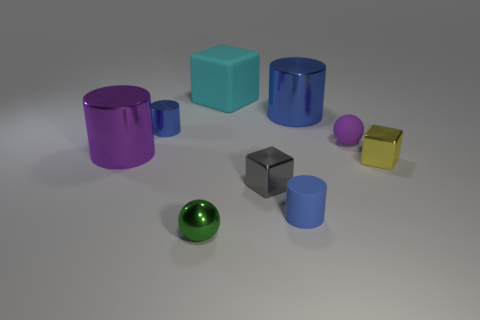There is a small cylinder on the right side of the large cyan block; is its color the same as the big shiny cylinder that is behind the tiny metal cylinder?
Ensure brevity in your answer.  Yes. Is the number of blue cylinders behind the purple rubber thing greater than the number of large blue objects?
Give a very brief answer. Yes. What is the material of the green ball?
Make the answer very short. Metal. What is the shape of the tiny yellow object that is made of the same material as the purple cylinder?
Your response must be concise. Cube. There is a rubber thing behind the small sphere that is to the right of the large rubber block; what is its size?
Your answer should be compact. Large. There is a large cylinder that is on the left side of the big matte object; what is its color?
Ensure brevity in your answer.  Purple. Are there any large blue shiny objects of the same shape as the tiny green object?
Your answer should be very brief. No. Is the number of cyan objects on the right side of the yellow shiny object less than the number of small metallic cubes on the left side of the gray cube?
Keep it short and to the point. No. What is the color of the small matte cylinder?
Your answer should be very brief. Blue. There is a tiny green metal ball to the left of the big cyan thing; are there any big objects behind it?
Offer a very short reply. Yes. 